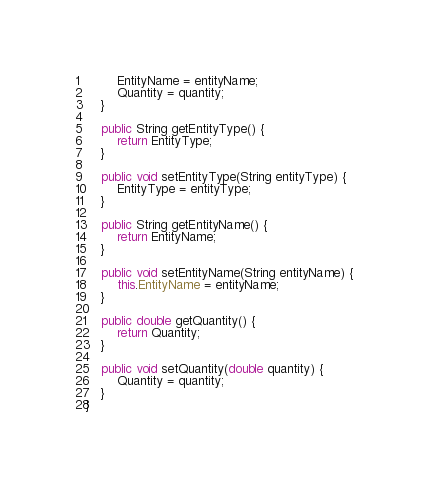Convert code to text. <code><loc_0><loc_0><loc_500><loc_500><_Java_>        EntityName = entityName;
        Quantity = quantity;
    }

    public String getEntityType() {
        return EntityType;
    }

    public void setEntityType(String entityType) {
        EntityType = entityType;
    }

    public String getEntityName() {
        return EntityName;
    }

    public void setEntityName(String entityName) {
        this.EntityName = entityName;
    }

    public double getQuantity() {
        return Quantity;
    }

    public void setQuantity(double quantity) {
        Quantity = quantity;
    }
}</code> 